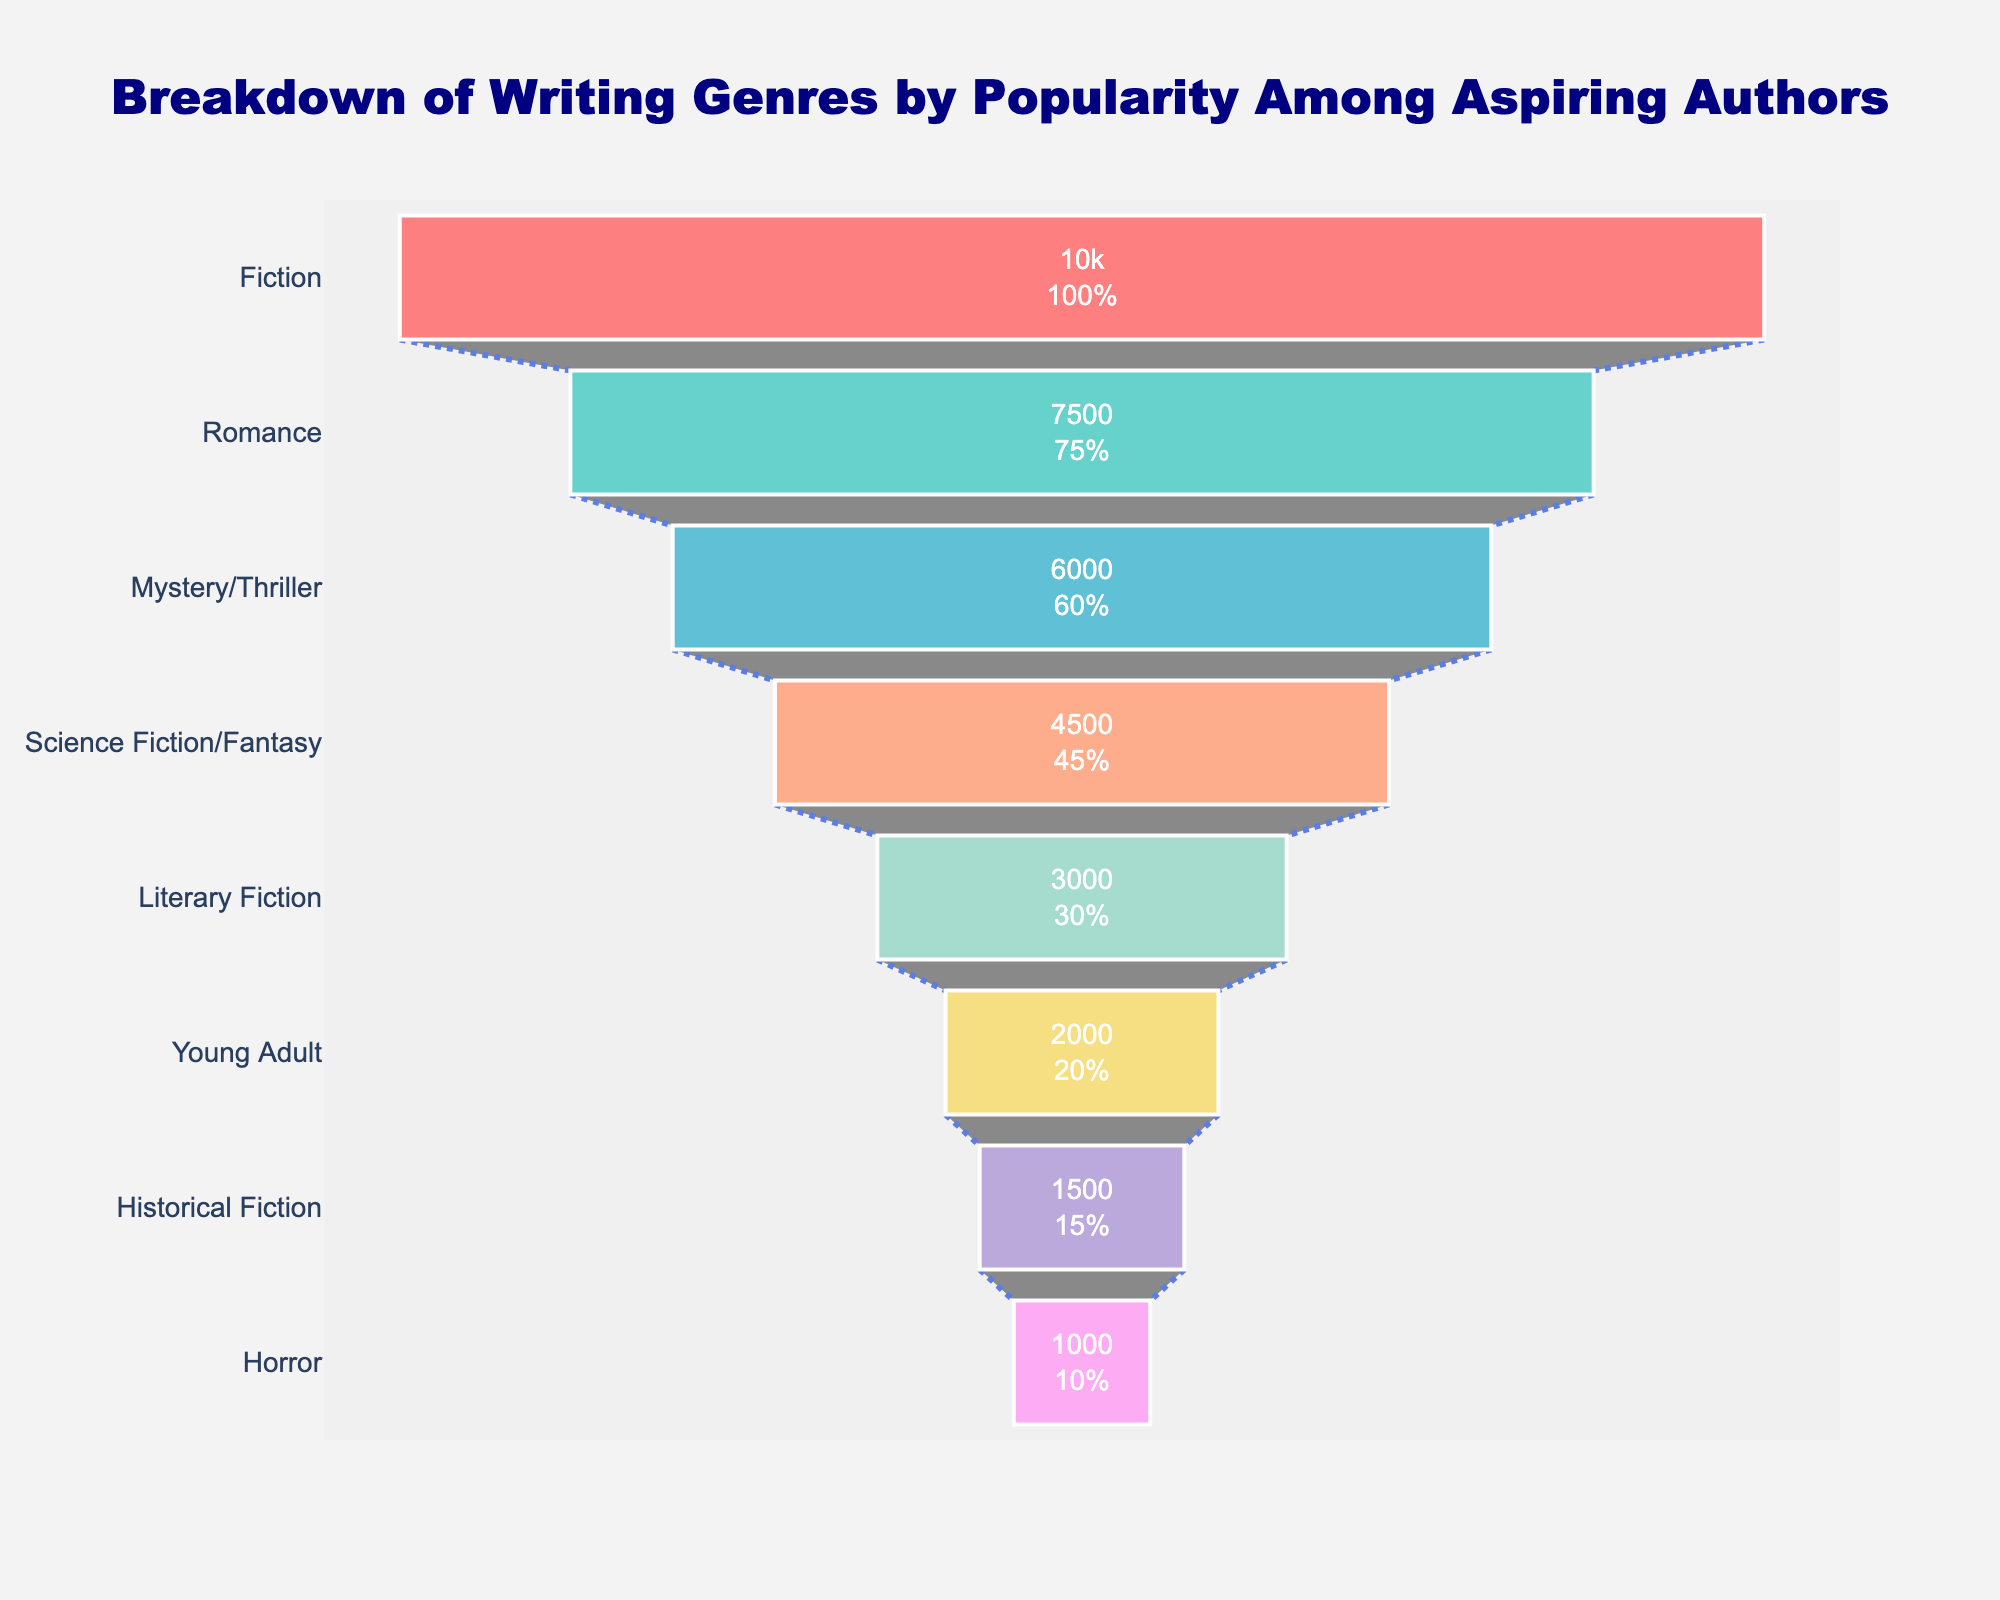What is the most popular writing genre among aspiring authors? The figure shows various writing genres listed from top to bottom by the number of aspiring authors. The genre at the top is the most popular one.
Answer: Fiction Which genre has the least number of aspiring authors? The genre at the bottom of the funnel represents the least number of aspiring authors.
Answer: Horror What percentage of aspiring authors prefer Romance? Find the segment labeled "Romance" and read the percentage value shown inside the segment.
Answer: 75% How does the popularity of Science Fiction/Fantasy compare to that of Literary Fiction? Locate both genres in the funnel chart and compare the number of aspiring authors for each. Science Fiction/Fantasy has 4500 authors, while Literary Fiction has 3000.
Answer: Science Fiction/Fantasy is more popular How many fewer authors are interested in Mystery/Thriller compared to Fiction? Find the number of aspiring authors for Mystery/Thriller and Fiction. Compute the difference: 10000 (Fiction) - 6000 (Mystery/Thriller) = 4000
Answer: 4000 fewer authors What is the combined number of aspiring authors for Fiction, Romance, and Mystery/Thriller? Sum the number of aspiring authors for these three genres: 10000 (Fiction) + 7500 (Romance) + 6000 (Mystery/Thriller) = 23500
Answer: 23500 What genre sits in the middle of the chart in terms of popularity? Locate the genre positioned in the middle of the funnel chart.
Answer: Literary Fiction Which has a higher number of aspiring authors: Historical Fiction or Young Adult? Locate both genres on the chart and compare their numbers. Young Adult has 2000 authors, while Historical Fiction has 1500.
Answer: Young Adult How much more popular is Romance compared to Horror? Subtract the number of aspiring authors for Horror from Romance: 7500 (Romance) - 1000 (Horror) = 6500
Answer: 6500 more authors What color represents the genre with the second-highest number of aspiring authors? Identify the second genre from the top (Romance) and find its corresponding color in the chart.
Answer: Teal 